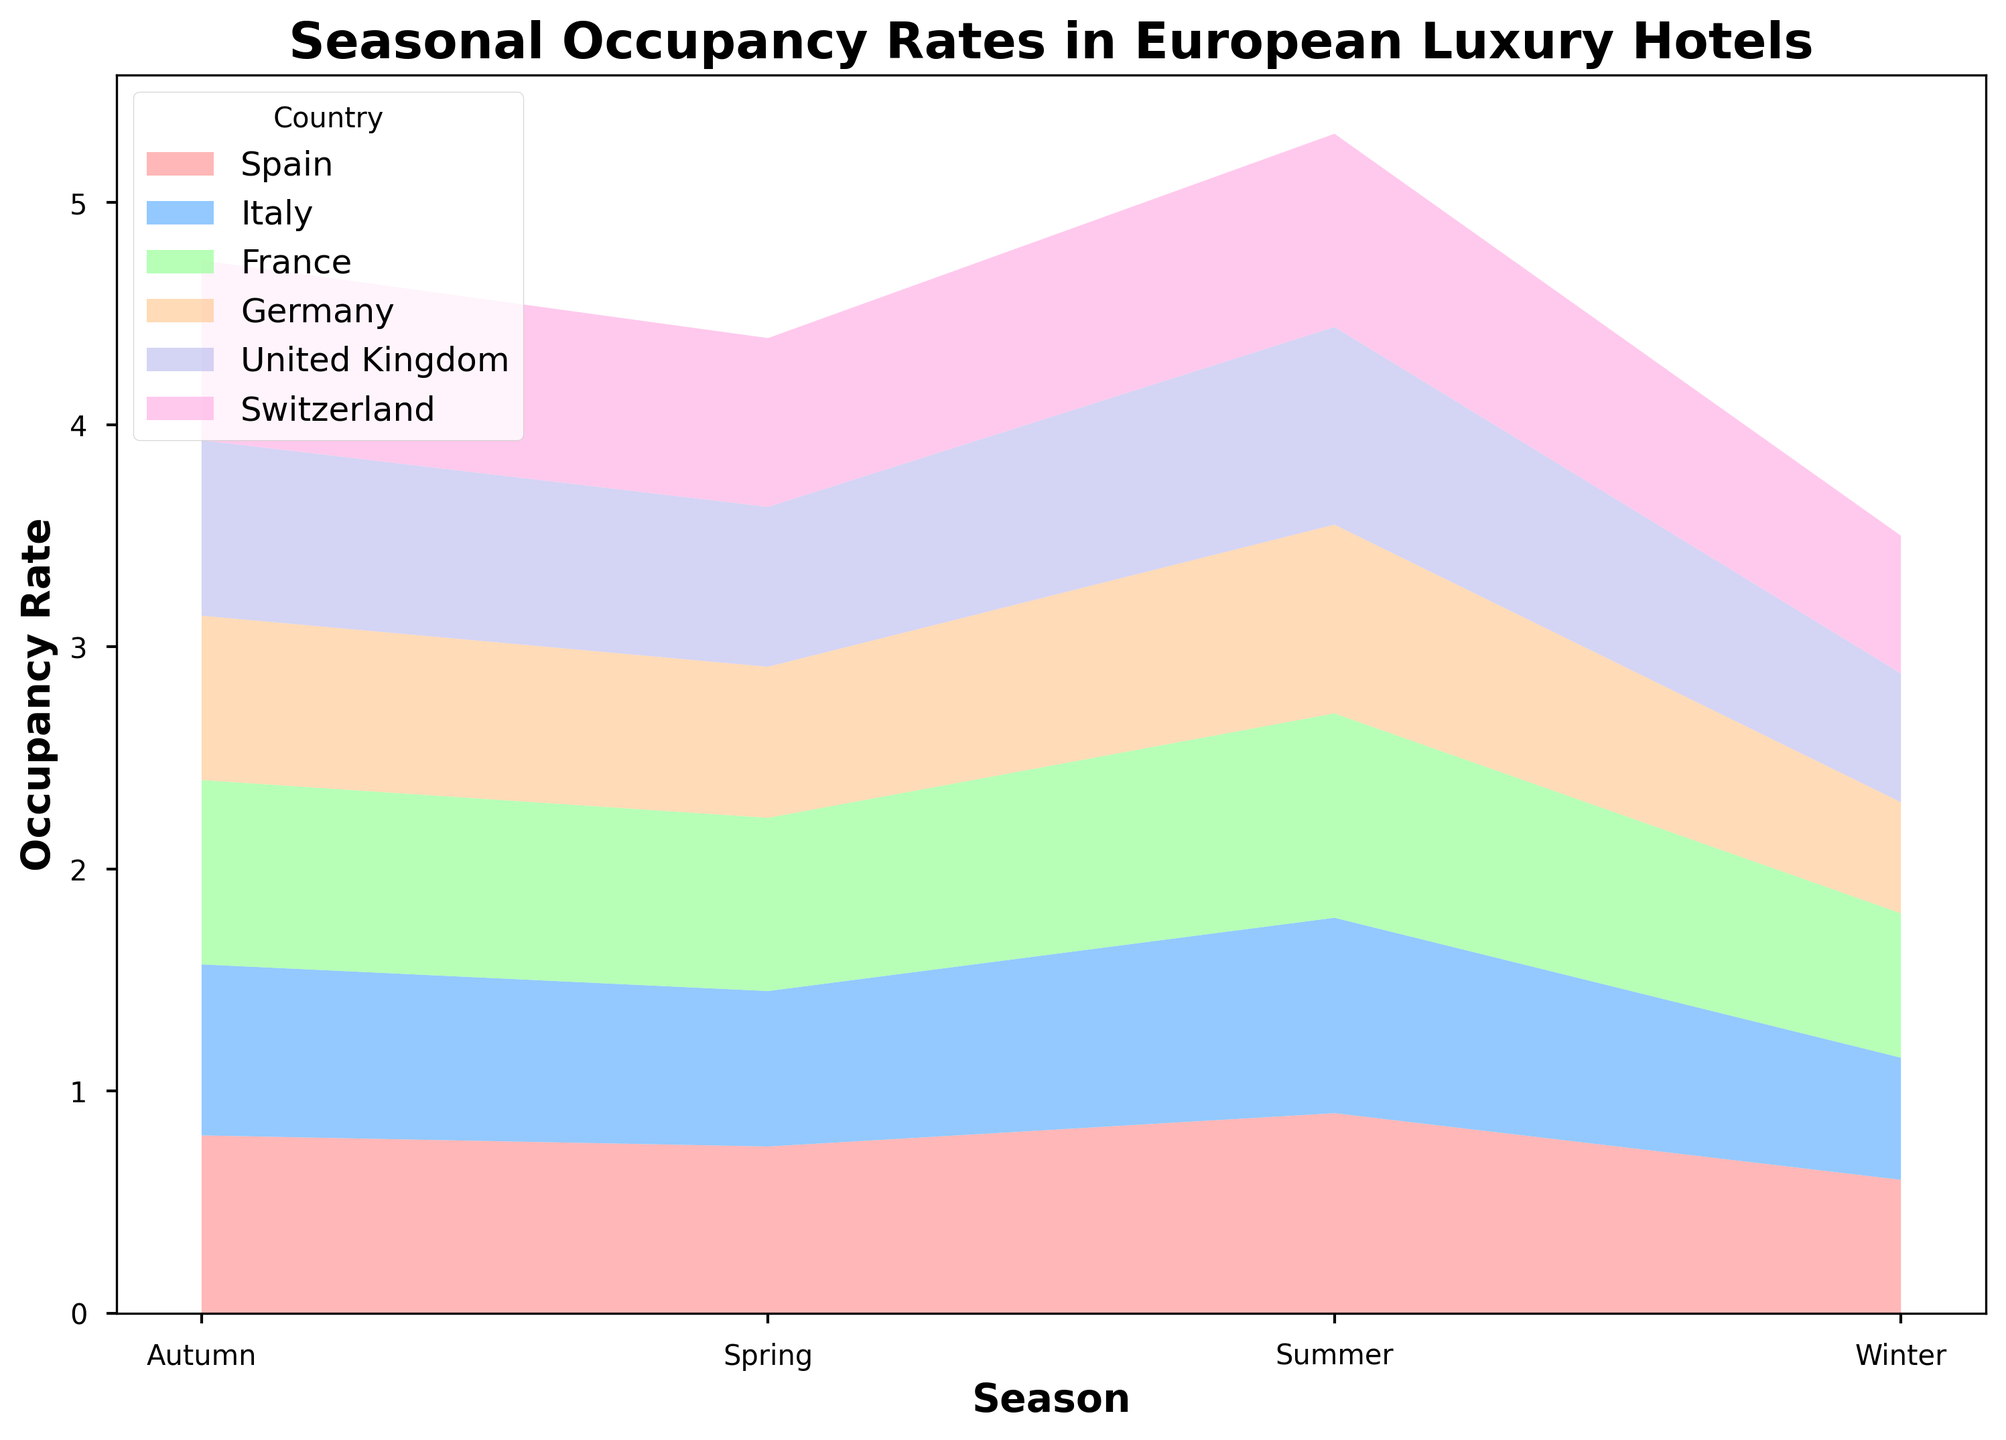How does the occupancy rate in summer compare between Spain and Germany? To compare the summer occupancy rate, look at the area chart corresponding to "Summer" for Spain and Germany. Spain has a higher occupancy rate as its portion of the stack is larger than Germany's.
Answer: Spain's rate is higher What is the difference in occupancy rates between France and the United Kingdom in autumn? Observe the relative height of the "Autumn" sections for France and the United Kingdom. France's segment is larger than the United Kingdom's by 0.04 (0.83 - 0.79).
Answer: 0.04 Which country shows the highest occupancy rate in any season, and during which season? Look for the highest section in any season across all countries. The tallest bar segment visually is for France in "Summer" with an occupancy rate of 0.92.
Answer: France in Summer If the average occupancy rate for all countries combined in spring is calculated, what would it be? Sum the occupancy rates for all countries in spring (0.75 + 0.70 + 0.78 + 0.68 + 0.72 + 0.76) and divide by the number of countries (6). The calculation is (0.75 + 0.70 + 0.78 + 0.68 + 0.72 + 0.76) / 6 = 4.39 / 6 = 0.7317.
Answer: 0.73 Which country has the most consistent occupancy rate across different seasons, and how can you tell? Consistency can be assessed by visually examining how the height of the sections changes across seasons. Switzerland's sections have the least variation visually, indicating more consistent occupancy rates.
Answer: Switzerland In which season does Italy see its maximum occupancy rates, and what is the rate? Examine Italy's sections across all seasons and identify the largest segment. Italy's occupancy rate is highest in "Summer" at 0.88.
Answer: Summer, 0.88 How much higher is the occupancy rate in Switzerland during autumn compared to winter? Look at Switzerland's segments in "Autumn" and "Winter." Subtract the winter rate from the autumn rate (0.81 - 0.62).
Answer: 0.19 